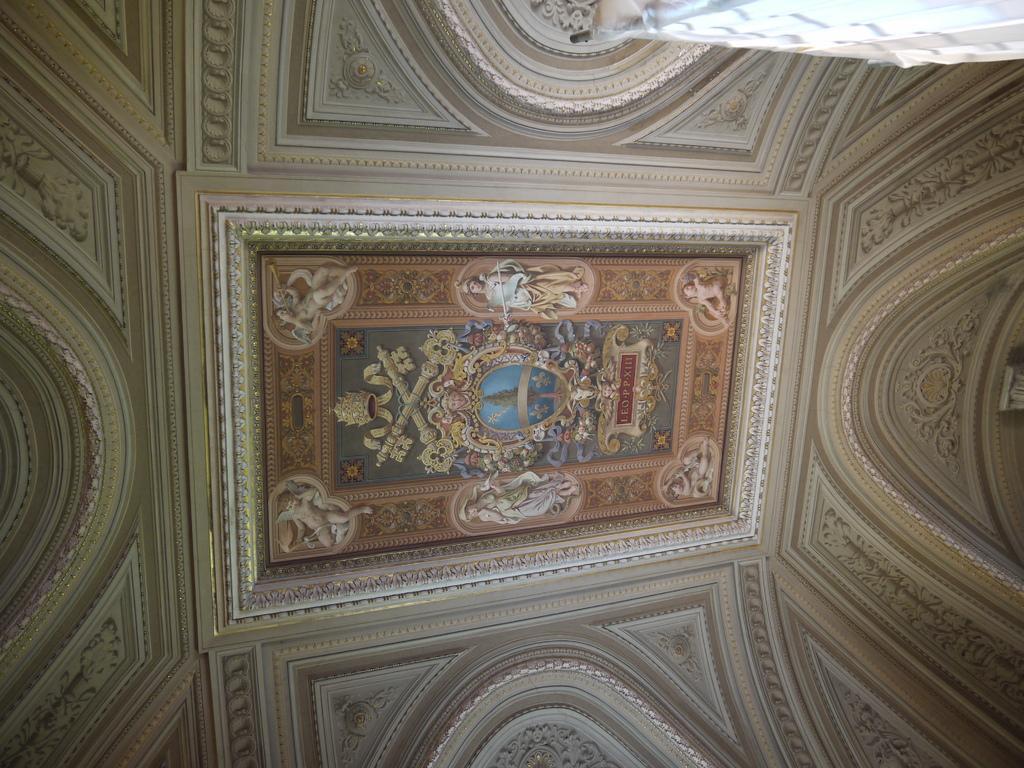In one or two sentences, can you explain what this image depicts? In this picture it looks like the ceiling, we can see pictures of persons and a tree in the middle. 